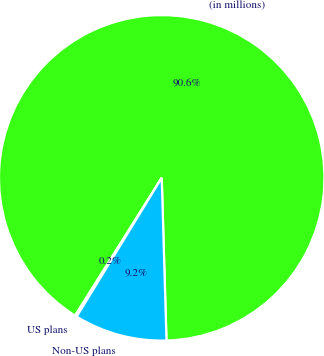<chart> <loc_0><loc_0><loc_500><loc_500><pie_chart><fcel>(in millions)<fcel>US plans<fcel>Non-US plans<nl><fcel>90.6%<fcel>0.18%<fcel>9.22%<nl></chart> 